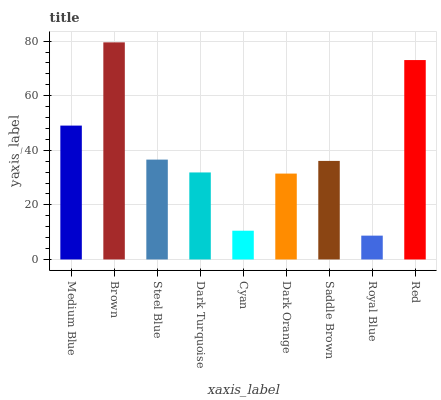Is Steel Blue the minimum?
Answer yes or no. No. Is Steel Blue the maximum?
Answer yes or no. No. Is Brown greater than Steel Blue?
Answer yes or no. Yes. Is Steel Blue less than Brown?
Answer yes or no. Yes. Is Steel Blue greater than Brown?
Answer yes or no. No. Is Brown less than Steel Blue?
Answer yes or no. No. Is Saddle Brown the high median?
Answer yes or no. Yes. Is Saddle Brown the low median?
Answer yes or no. Yes. Is Steel Blue the high median?
Answer yes or no. No. Is Cyan the low median?
Answer yes or no. No. 